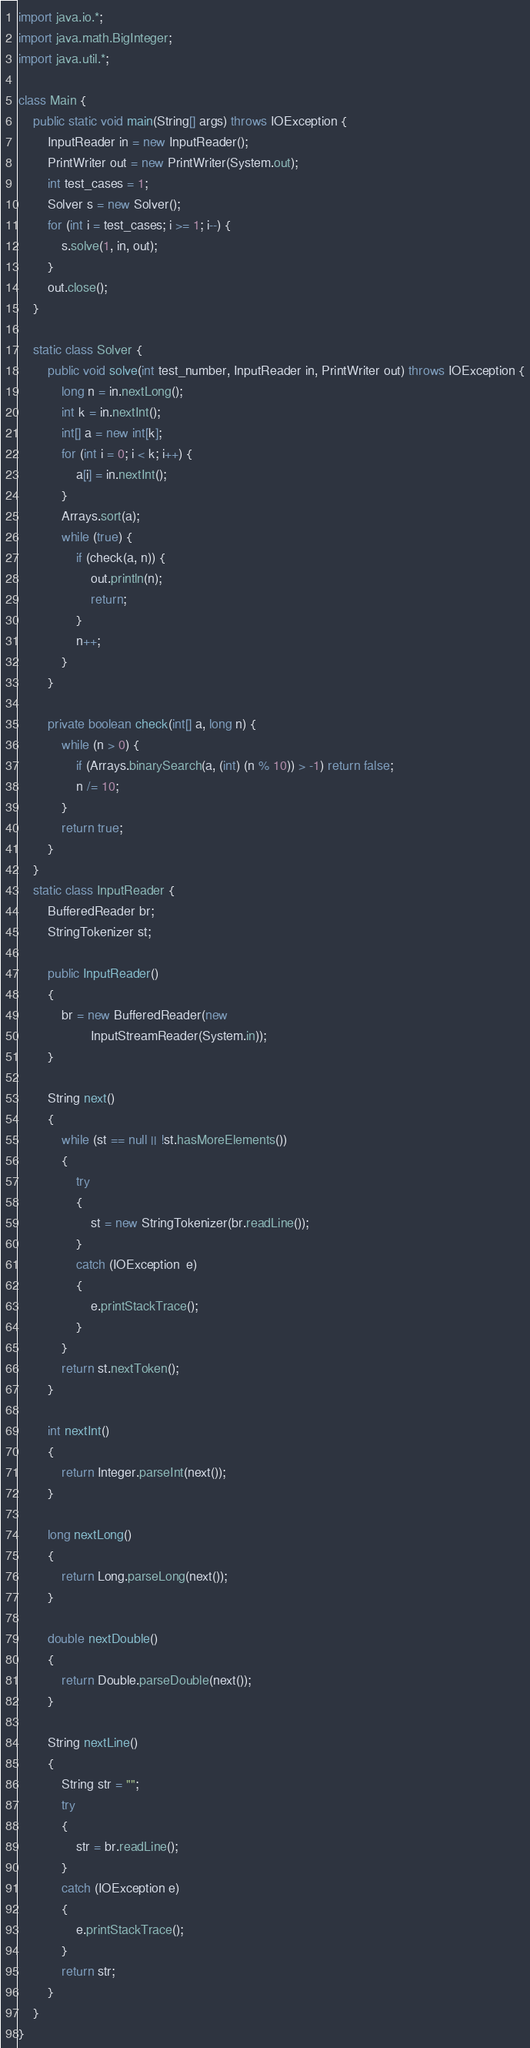<code> <loc_0><loc_0><loc_500><loc_500><_Java_>import java.io.*;
import java.math.BigInteger;
import java.util.*;

class Main {
    public static void main(String[] args) throws IOException {
        InputReader in = new InputReader();
        PrintWriter out = new PrintWriter(System.out);
        int test_cases = 1;
        Solver s = new Solver();
        for (int i = test_cases; i >= 1; i--) {
            s.solve(1, in, out);
        }
        out.close();
    }

    static class Solver {
        public void solve(int test_number, InputReader in, PrintWriter out) throws IOException {
            long n = in.nextLong();
            int k = in.nextInt();
            int[] a = new int[k];
            for (int i = 0; i < k; i++) {
                a[i] = in.nextInt();
            }
            Arrays.sort(a);
            while (true) {
                if (check(a, n)) {
                    out.println(n);
                    return;
                }
                n++;
            }
        }

        private boolean check(int[] a, long n) {
            while (n > 0) {
                if (Arrays.binarySearch(a, (int) (n % 10)) > -1) return false;
                n /= 10;
            }
            return true;
        }
    }
    static class InputReader {
        BufferedReader br;
        StringTokenizer st;

        public InputReader()
        {
            br = new BufferedReader(new
                    InputStreamReader(System.in));
        }

        String next()
        {
            while (st == null || !st.hasMoreElements())
            {
                try
                {
                    st = new StringTokenizer(br.readLine());
                }
                catch (IOException  e)
                {
                    e.printStackTrace();
                }
            }
            return st.nextToken();
        }

        int nextInt()
        {
            return Integer.parseInt(next());
        }

        long nextLong()
        {
            return Long.parseLong(next());
        }

        double nextDouble()
        {
            return Double.parseDouble(next());
        }

        String nextLine()
        {
            String str = "";
            try
            {
                str = br.readLine();
            }
            catch (IOException e)
            {
                e.printStackTrace();
            }
            return str;
        }
    }
}</code> 